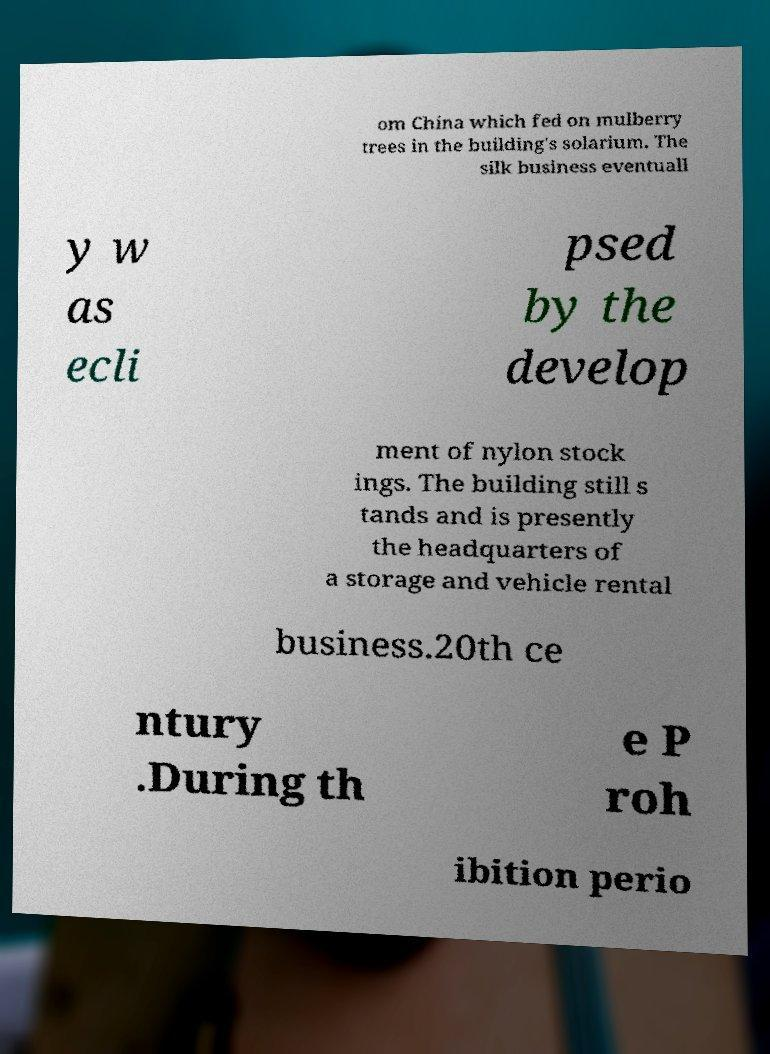Please identify and transcribe the text found in this image. om China which fed on mulberry trees in the building's solarium. The silk business eventuall y w as ecli psed by the develop ment of nylon stock ings. The building still s tands and is presently the headquarters of a storage and vehicle rental business.20th ce ntury .During th e P roh ibition perio 